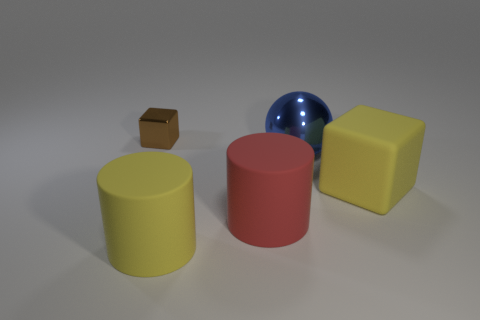There is a object that is on the left side of the big yellow object on the left side of the yellow object that is right of the shiny ball; what is it made of?
Your answer should be very brief. Metal. Is there anything else that is the same size as the brown metallic block?
Keep it short and to the point. No. What number of rubber things are either big cyan objects or big yellow things?
Give a very brief answer. 2. Are there any tiny blue balls?
Your answer should be compact. No. What color is the cube that is to the right of the block behind the matte block?
Make the answer very short. Yellow. How many other things are there of the same color as the tiny shiny cube?
Give a very brief answer. 0. How many things are cyan rubber cylinders or yellow things that are in front of the yellow block?
Offer a very short reply. 1. What color is the block on the right side of the tiny brown shiny object?
Give a very brief answer. Yellow. There is a tiny metal object; what shape is it?
Give a very brief answer. Cube. The block on the left side of the yellow object that is behind the large yellow rubber cylinder is made of what material?
Make the answer very short. Metal. 